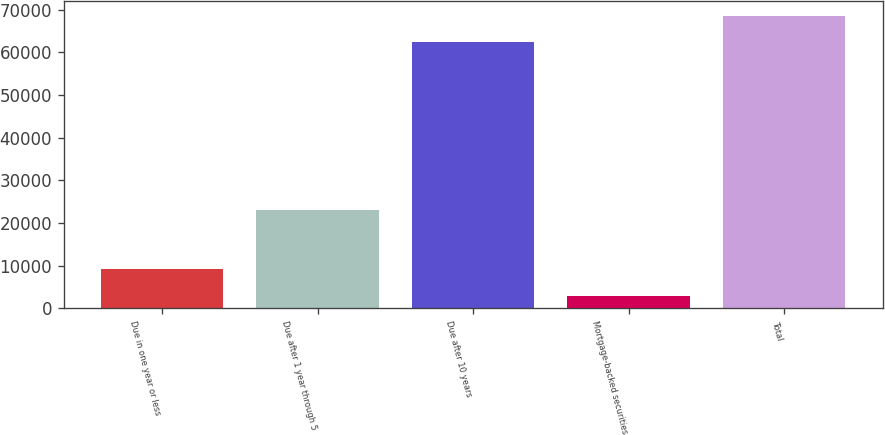Convert chart. <chart><loc_0><loc_0><loc_500><loc_500><bar_chart><fcel>Due in one year or less<fcel>Due after 1 year through 5<fcel>Due after 10 years<fcel>Mortgage-backed securities<fcel>Total<nl><fcel>9236.6<fcel>22944<fcel>62396<fcel>2997<fcel>68635.6<nl></chart> 